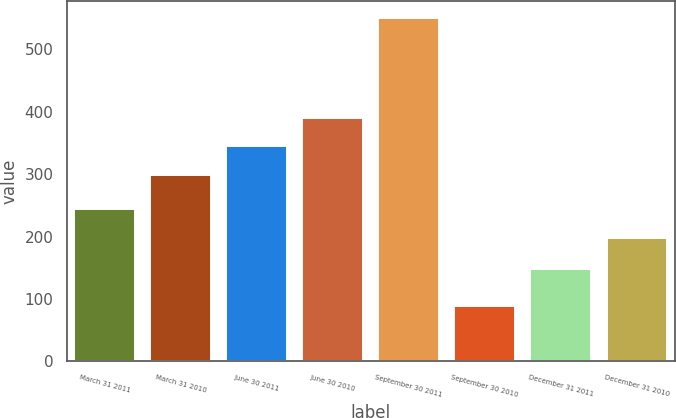<chart> <loc_0><loc_0><loc_500><loc_500><bar_chart><fcel>March 31 2011<fcel>March 31 2010<fcel>June 30 2011<fcel>June 30 2010<fcel>September 30 2011<fcel>September 30 2010<fcel>December 31 2011<fcel>December 31 2010<nl><fcel>244.1<fcel>298<fcel>344.1<fcel>390.2<fcel>550<fcel>89<fcel>148<fcel>198<nl></chart> 